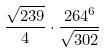Convert formula to latex. <formula><loc_0><loc_0><loc_500><loc_500>\frac { \sqrt { 2 3 9 } } { 4 } \cdot \frac { 2 6 4 ^ { 6 } } { \sqrt { 3 0 2 } }</formula> 